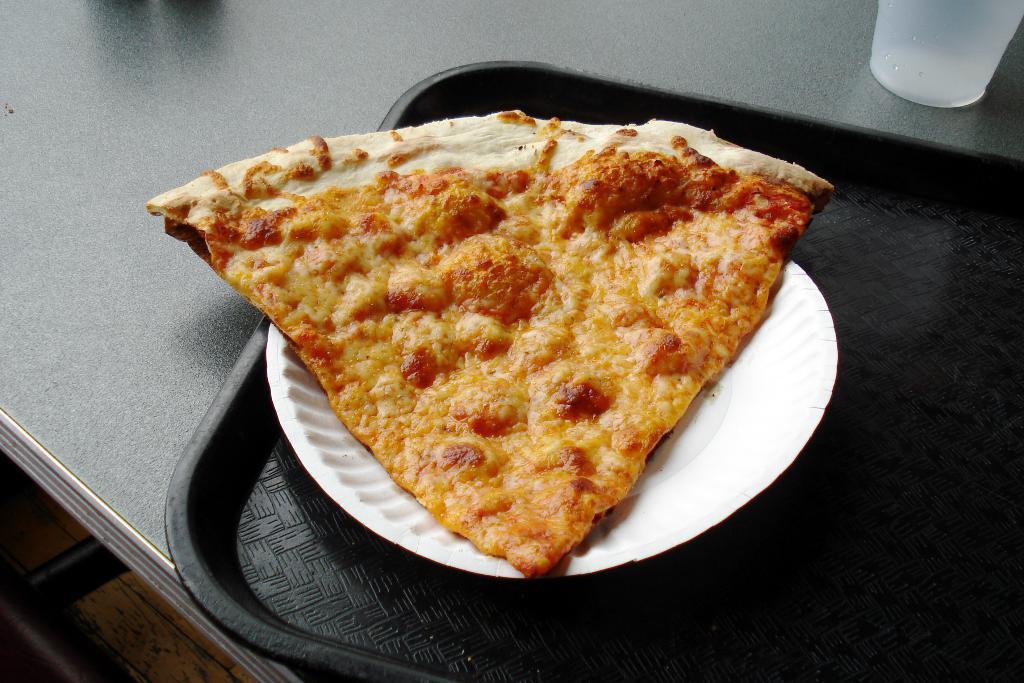Please provide a concise description of this image. In this image there is a table. There is a plate on the table. There is a food item on the plate. There is a glass. 